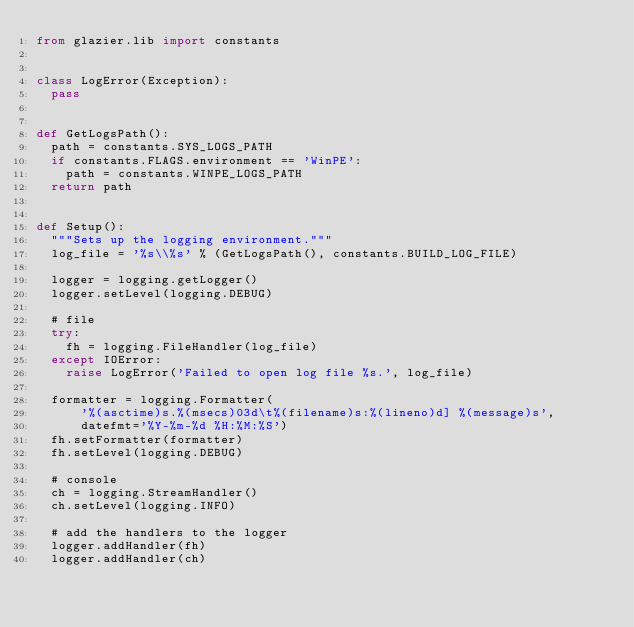Convert code to text. <code><loc_0><loc_0><loc_500><loc_500><_Python_>from glazier.lib import constants


class LogError(Exception):
  pass


def GetLogsPath():
  path = constants.SYS_LOGS_PATH
  if constants.FLAGS.environment == 'WinPE':
    path = constants.WINPE_LOGS_PATH
  return path


def Setup():
  """Sets up the logging environment."""
  log_file = '%s\\%s' % (GetLogsPath(), constants.BUILD_LOG_FILE)

  logger = logging.getLogger()
  logger.setLevel(logging.DEBUG)

  # file
  try:
    fh = logging.FileHandler(log_file)
  except IOError:
    raise LogError('Failed to open log file %s.', log_file)

  formatter = logging.Formatter(
      '%(asctime)s.%(msecs)03d\t%(filename)s:%(lineno)d] %(message)s',
      datefmt='%Y-%m-%d %H:%M:%S')
  fh.setFormatter(formatter)
  fh.setLevel(logging.DEBUG)

  # console
  ch = logging.StreamHandler()
  ch.setLevel(logging.INFO)

  # add the handlers to the logger
  logger.addHandler(fh)
  logger.addHandler(ch)
</code> 